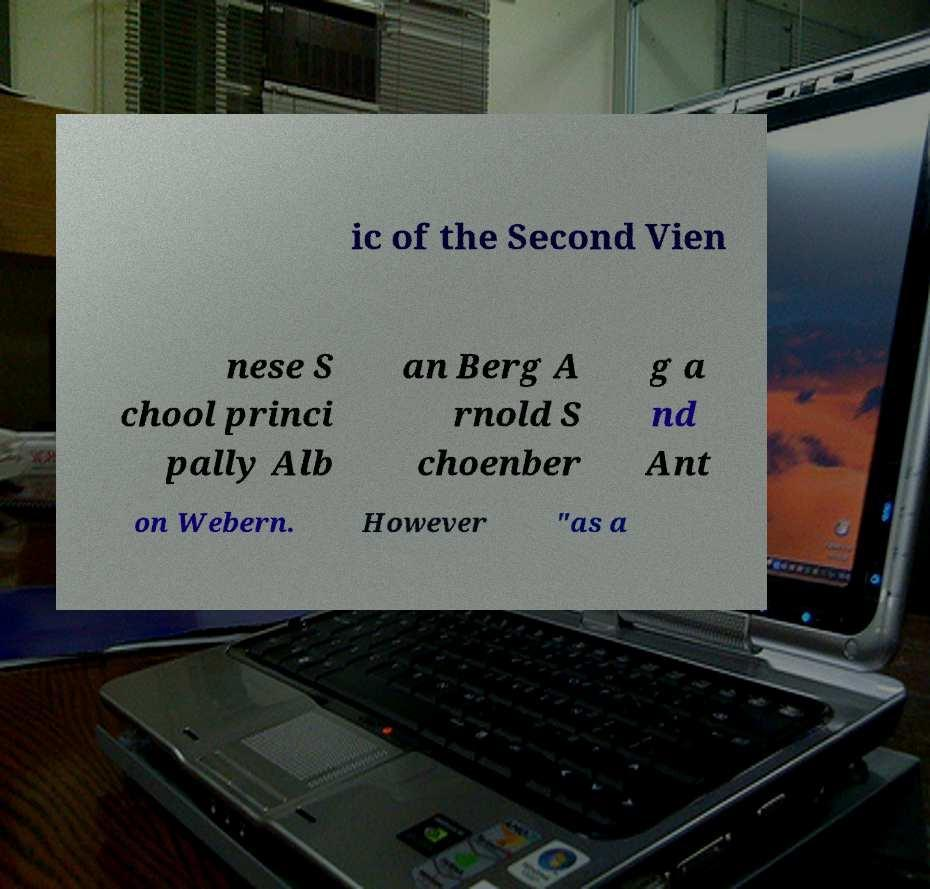Could you extract and type out the text from this image? ic of the Second Vien nese S chool princi pally Alb an Berg A rnold S choenber g a nd Ant on Webern. However "as a 